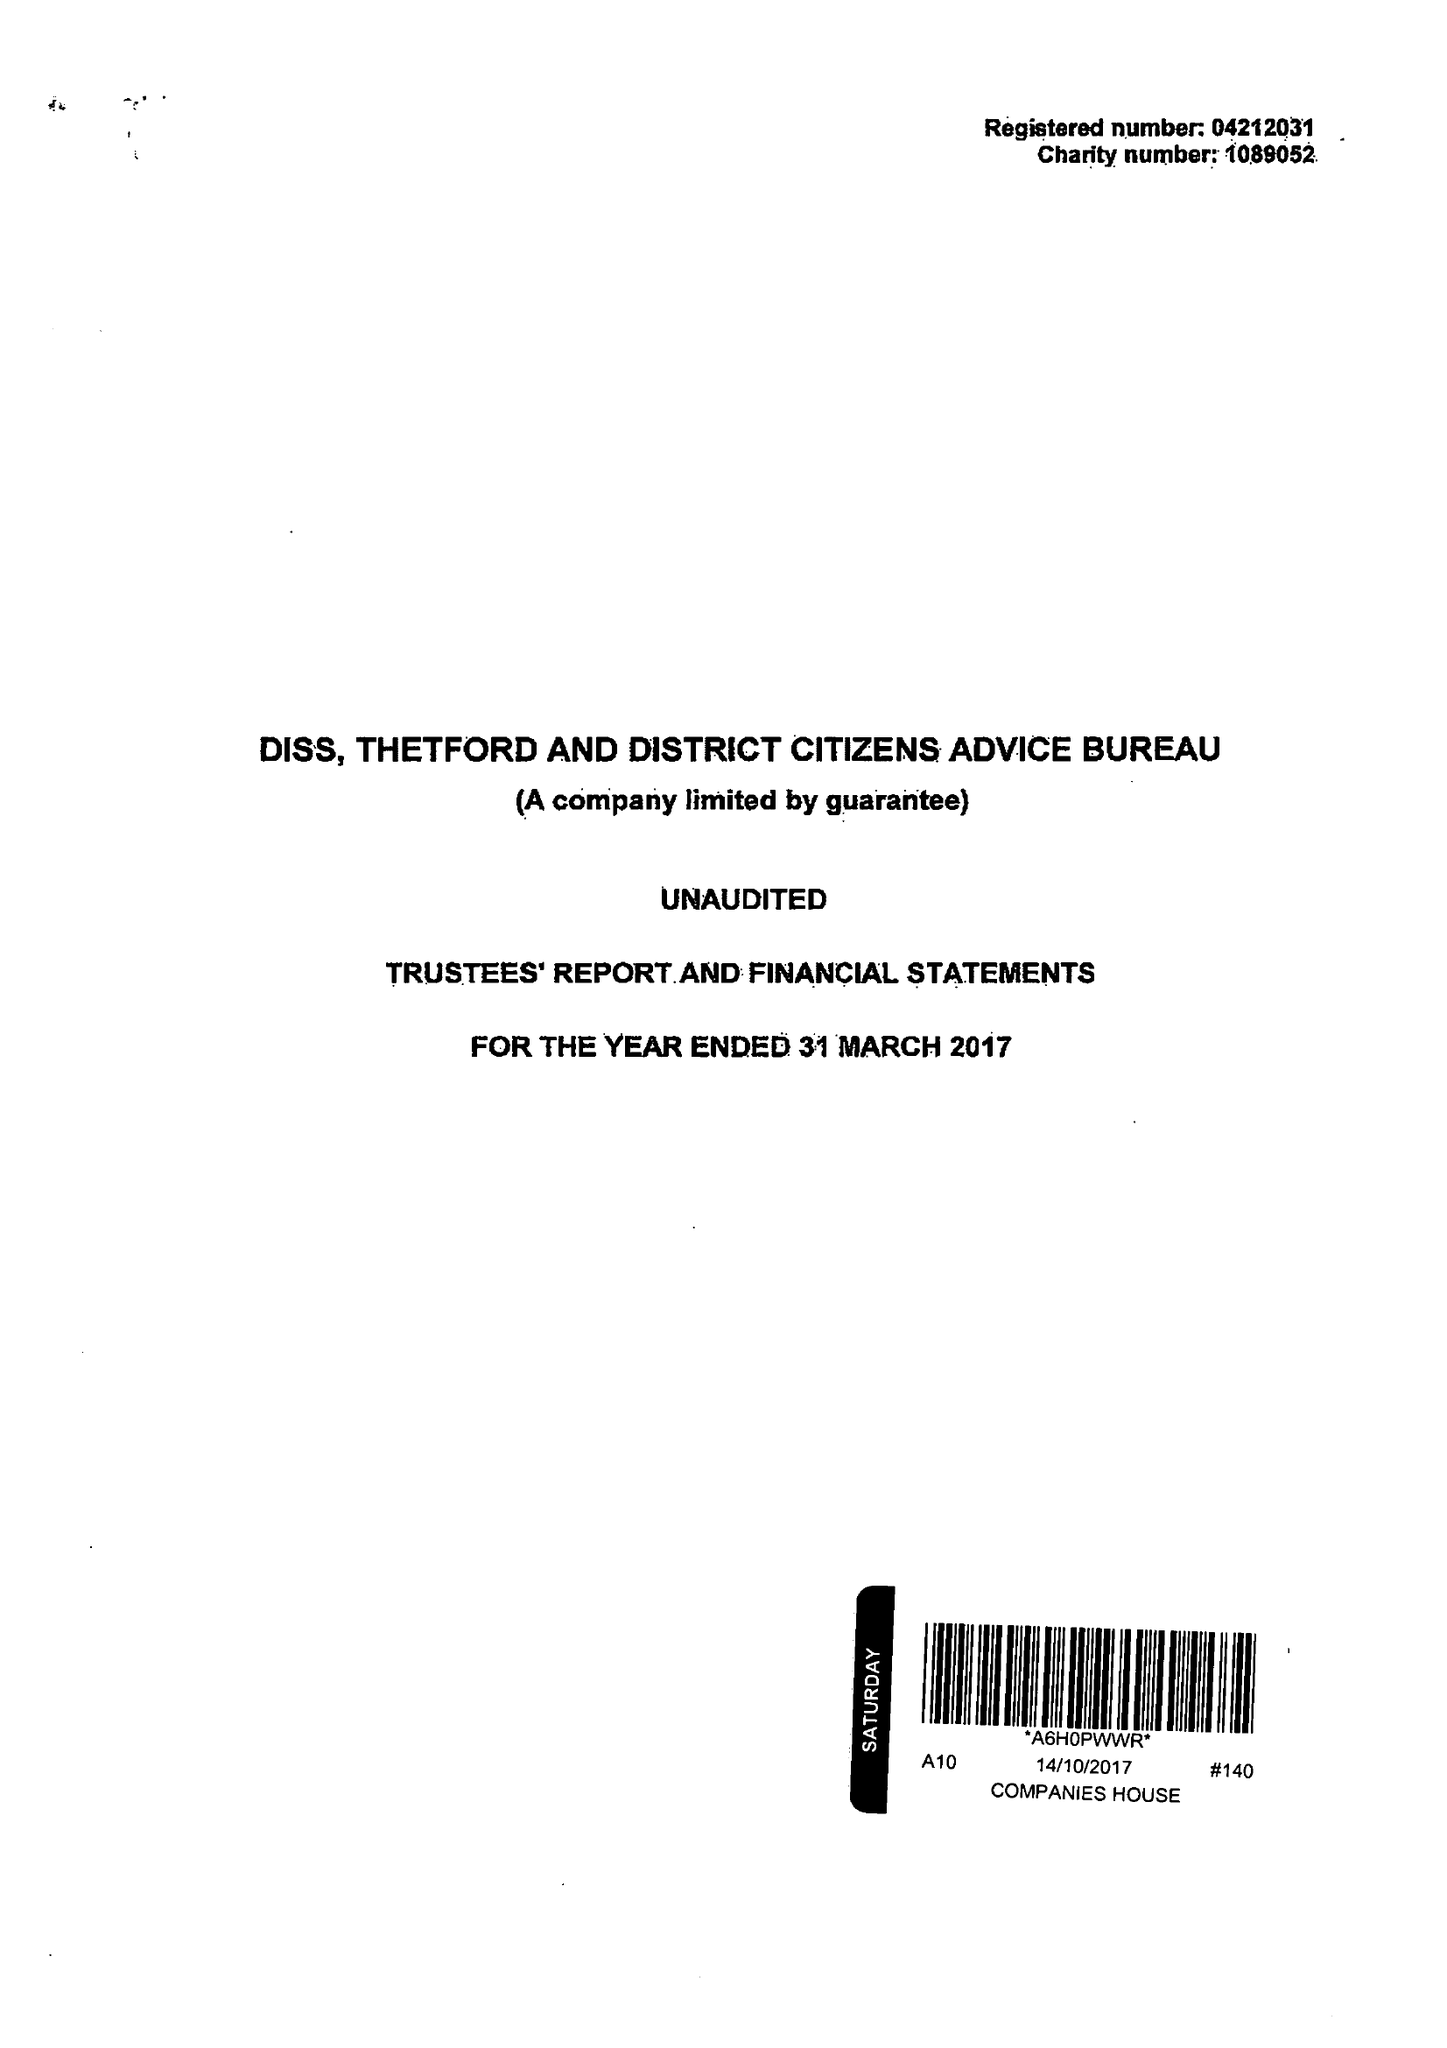What is the value for the charity_name?
Answer the question using a single word or phrase. Diss, Thetford and District Citizens Advice Bureau 